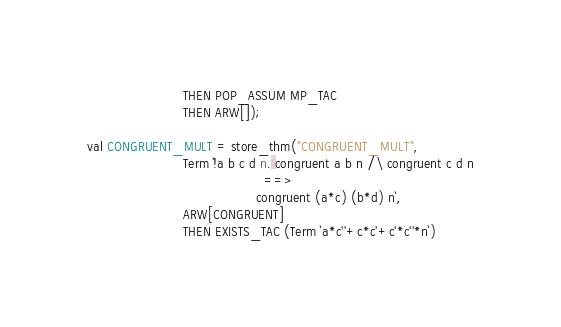Convert code to text. <code><loc_0><loc_0><loc_500><loc_500><_SML_>                        THEN POP_ASSUM MP_TAC
                        THEN ARW[]);

val CONGRUENT_MULT = store_thm("CONGRUENT_MULT",
                        Term `!a b c d n. congruent a b n /\ congruent c d n
                                            ==>
                                          congruent (a*c) (b*d) n`,
                        ARW[CONGRUENT]
                        THEN EXISTS_TAC (Term `a*c''+c*c'+c'*c''*n`)</code> 